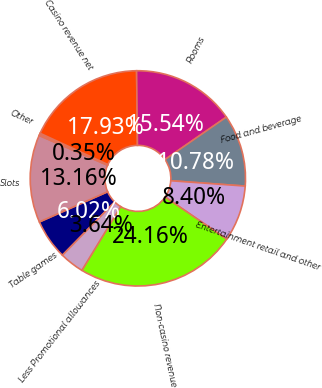Convert chart to OTSL. <chart><loc_0><loc_0><loc_500><loc_500><pie_chart><fcel>Table games<fcel>Slots<fcel>Other<fcel>Casino revenue net<fcel>Rooms<fcel>Food and beverage<fcel>Entertainment retail and other<fcel>Non-casino revenue<fcel>Less Promotional allowances<nl><fcel>6.02%<fcel>13.16%<fcel>0.35%<fcel>17.93%<fcel>15.54%<fcel>10.78%<fcel>8.4%<fcel>24.16%<fcel>3.64%<nl></chart> 